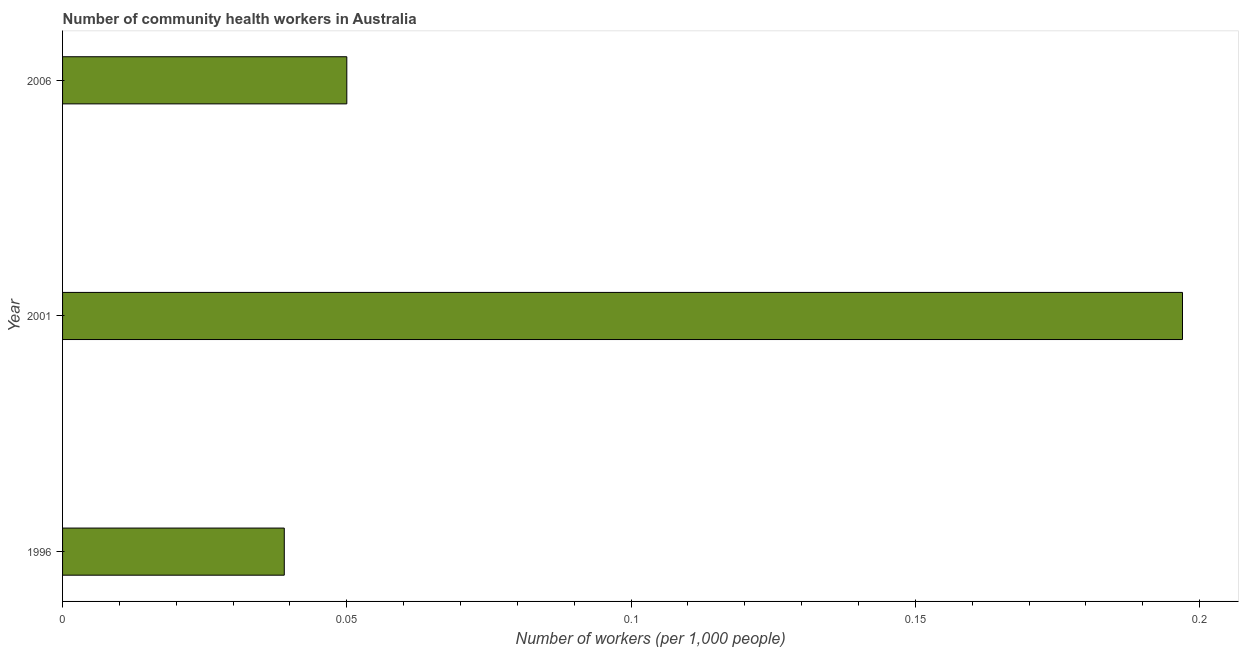What is the title of the graph?
Keep it short and to the point. Number of community health workers in Australia. What is the label or title of the X-axis?
Keep it short and to the point. Number of workers (per 1,0 people). What is the number of community health workers in 2006?
Keep it short and to the point. 0.05. Across all years, what is the maximum number of community health workers?
Offer a terse response. 0.2. Across all years, what is the minimum number of community health workers?
Ensure brevity in your answer.  0.04. In which year was the number of community health workers maximum?
Offer a terse response. 2001. In which year was the number of community health workers minimum?
Your response must be concise. 1996. What is the sum of the number of community health workers?
Ensure brevity in your answer.  0.29. What is the difference between the number of community health workers in 2001 and 2006?
Give a very brief answer. 0.15. What is the average number of community health workers per year?
Make the answer very short. 0.1. What is the ratio of the number of community health workers in 1996 to that in 2001?
Your response must be concise. 0.2. Is the number of community health workers in 2001 less than that in 2006?
Your answer should be very brief. No. What is the difference between the highest and the second highest number of community health workers?
Give a very brief answer. 0.15. Is the sum of the number of community health workers in 1996 and 2001 greater than the maximum number of community health workers across all years?
Offer a terse response. Yes. What is the difference between the highest and the lowest number of community health workers?
Your answer should be compact. 0.16. Are all the bars in the graph horizontal?
Your answer should be very brief. Yes. What is the Number of workers (per 1,000 people) of 1996?
Keep it short and to the point. 0.04. What is the Number of workers (per 1,000 people) in 2001?
Provide a succinct answer. 0.2. What is the difference between the Number of workers (per 1,000 people) in 1996 and 2001?
Provide a succinct answer. -0.16. What is the difference between the Number of workers (per 1,000 people) in 1996 and 2006?
Give a very brief answer. -0.01. What is the difference between the Number of workers (per 1,000 people) in 2001 and 2006?
Keep it short and to the point. 0.15. What is the ratio of the Number of workers (per 1,000 people) in 1996 to that in 2001?
Keep it short and to the point. 0.2. What is the ratio of the Number of workers (per 1,000 people) in 1996 to that in 2006?
Provide a short and direct response. 0.78. What is the ratio of the Number of workers (per 1,000 people) in 2001 to that in 2006?
Make the answer very short. 3.94. 